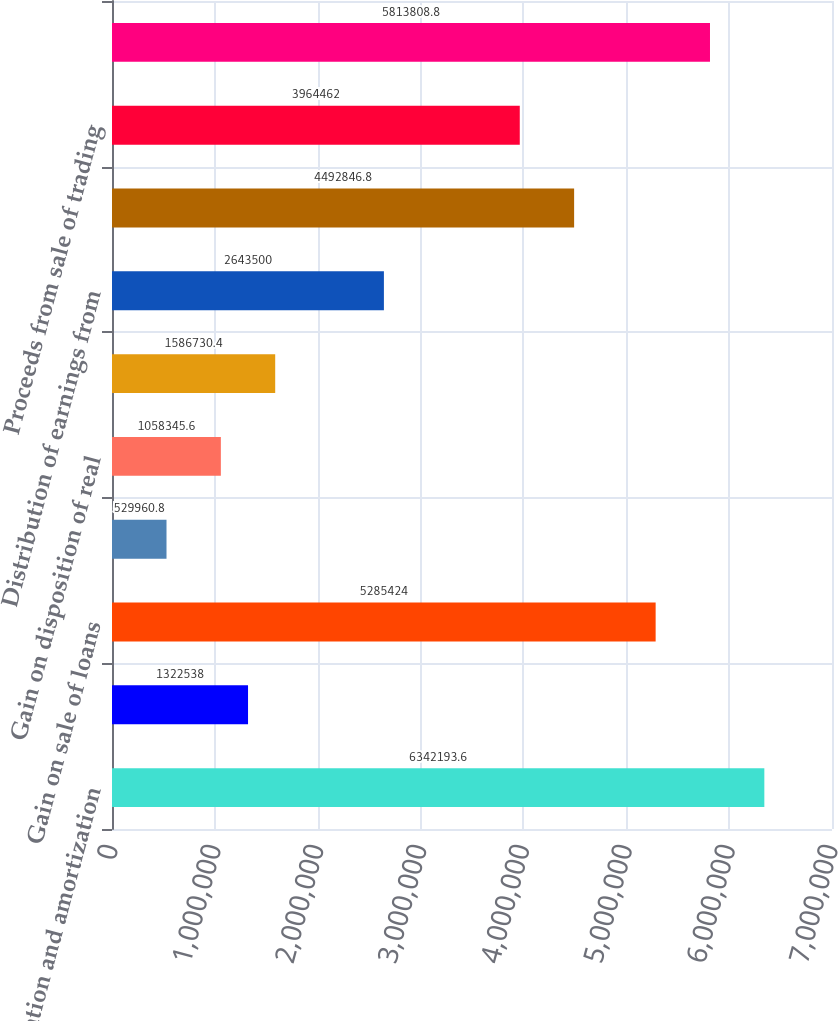<chart> <loc_0><loc_0><loc_500><loc_500><bar_chart><fcel>Depreciation and amortization<fcel>Amortization and write-off of<fcel>Gain on sale of loans<fcel>Net realized and unrealized<fcel>Gain on disposition of real<fcel>Deferred income taxes<fcel>Distribution of earnings from<fcel>Purchase of trading securities<fcel>Proceeds from sale of trading<fcel>Increase in receivables<nl><fcel>6.34219e+06<fcel>1.32254e+06<fcel>5.28542e+06<fcel>529961<fcel>1.05835e+06<fcel>1.58673e+06<fcel>2.6435e+06<fcel>4.49285e+06<fcel>3.96446e+06<fcel>5.81381e+06<nl></chart> 